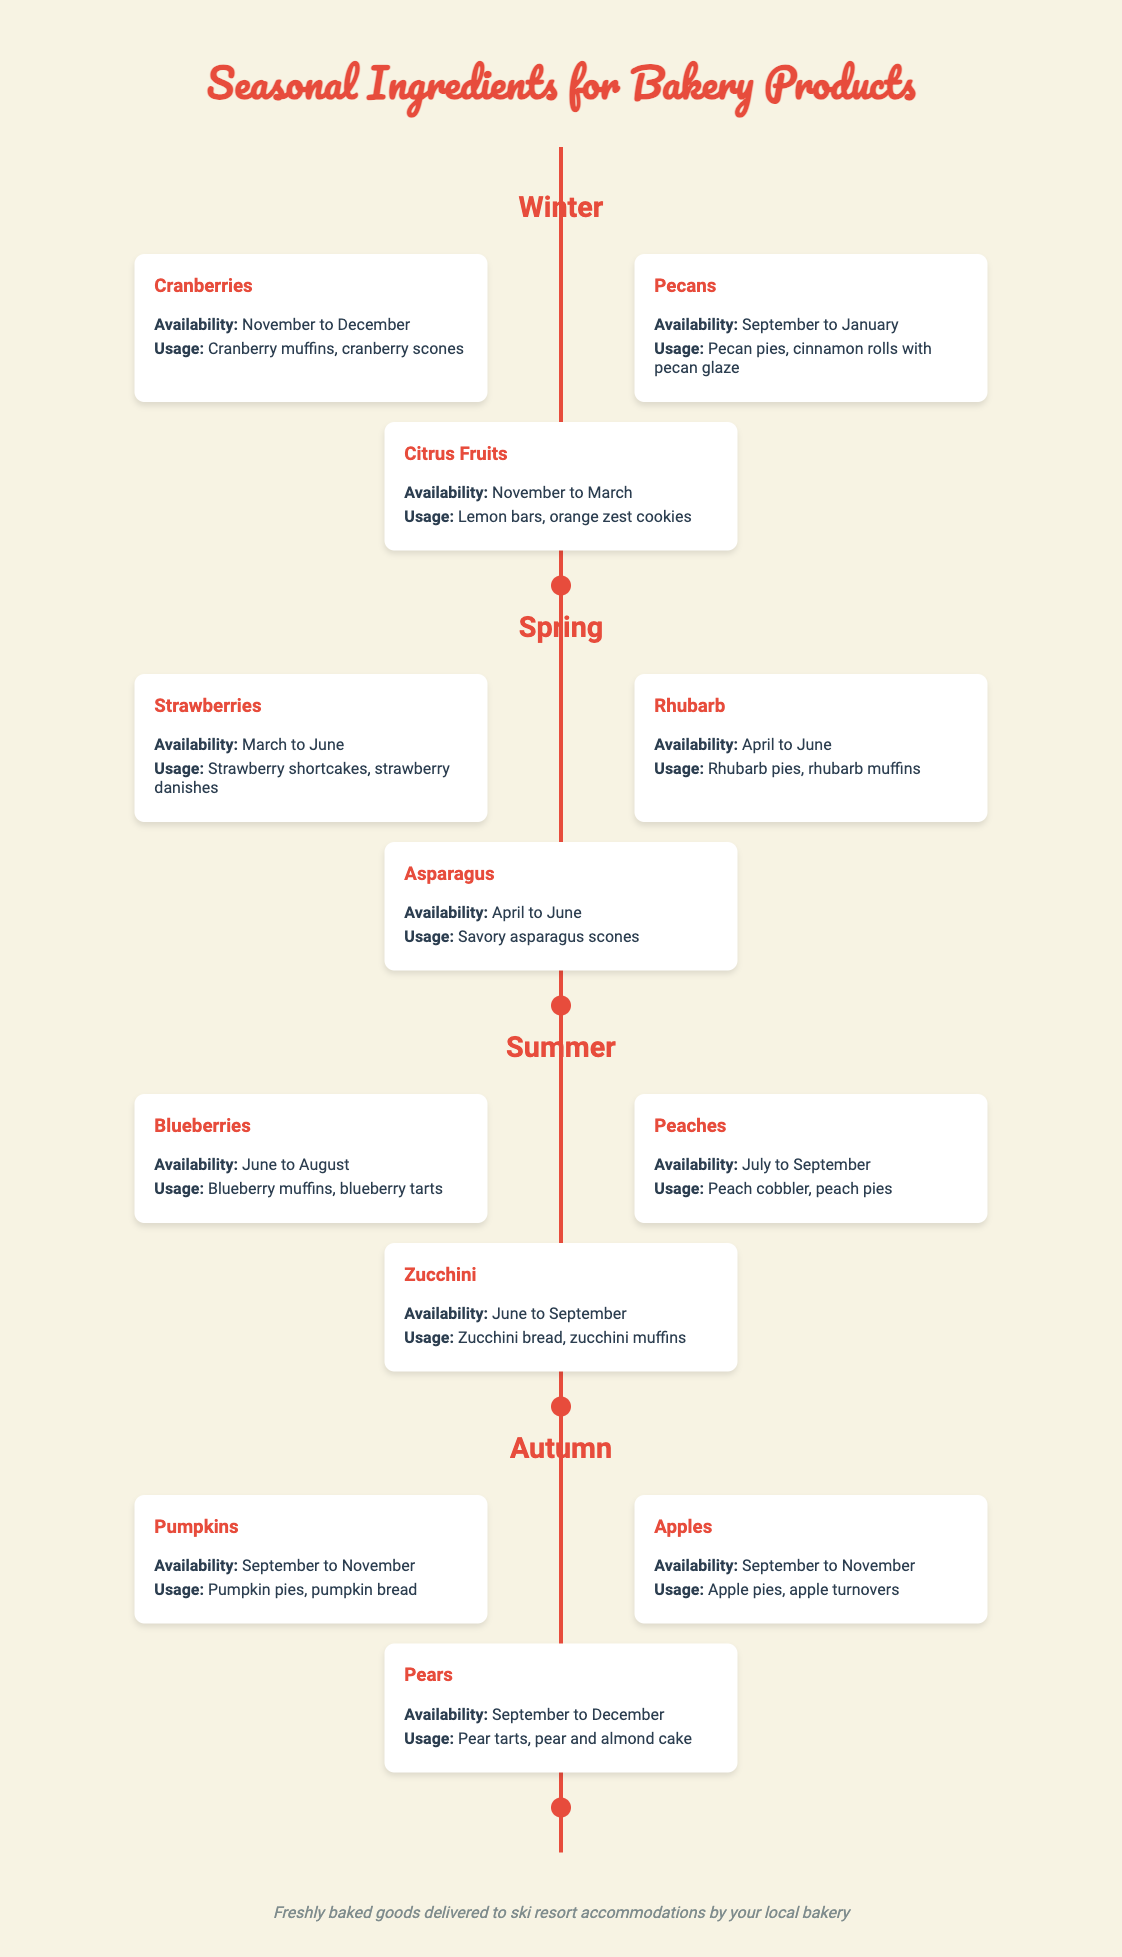What ingredients are available in Winter? The Winter season features cranberries, pecans, and citrus fruits as seasonal ingredients.
Answer: Cranberries, pecans, citrus fruits When are strawberries available? Strawberries are indicated to be available from March to June in the timeline.
Answer: March to June What type of dessert is made with rhubarb? The document mentions that rhubarb is used in rhubarb pies and rhubarb muffins.
Answer: Rhubarb pies, rhubarb muffins Which ingredient is found in Summer and has a usage for making tarts? Blueberries are highlighted in the Summer section and are used to make blueberry tarts.
Answer: Blueberries What season features pumpkins and apples as ingredients? The Autumn season includes both pumpkins and apples among its seasonal ingredients.
Answer: Autumn How many seasonal ingredients are listed for Spring? The Spring section features three seasonal ingredients: strawberries, rhubarb, and asparagus.
Answer: Three Which two fruits have overlapping availability in Autumn? Pumpkins and apples are both available from September to November, as noted in the Autumn section.
Answer: Pumpkins, apples What is the trend of ingredient availability from Winter to Autumn? The timeline shows a variety of ingredients becoming available throughout the year, with different fruits and vegetables peaking in their respective seasons.
Answer: Seasonal diversity 